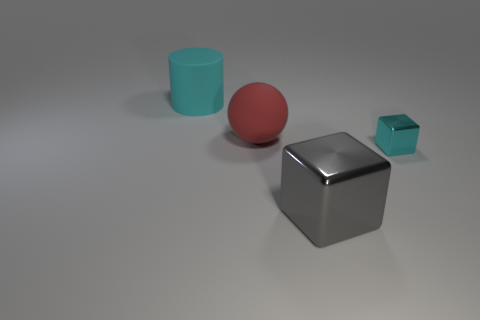What number of other cubes have the same material as the small cyan cube?
Your response must be concise. 1. Is there a small metallic block that is behind the matte object that is behind the large matte thing that is to the right of the cyan cylinder?
Ensure brevity in your answer.  No. What is the shape of the thing that is made of the same material as the large ball?
Your response must be concise. Cylinder. Are there more small cyan things than cyan shiny spheres?
Your response must be concise. Yes. There is a red matte thing; does it have the same shape as the metal thing to the right of the large metallic object?
Make the answer very short. No. What material is the big gray object?
Ensure brevity in your answer.  Metal. There is a big object that is to the right of the big matte thing that is in front of the cyan thing that is behind the large red thing; what is its color?
Offer a very short reply. Gray. There is a tiny cyan thing that is the same shape as the gray shiny object; what is it made of?
Ensure brevity in your answer.  Metal. What number of other red things have the same size as the red thing?
Ensure brevity in your answer.  0. How many gray cylinders are there?
Your response must be concise. 0. 